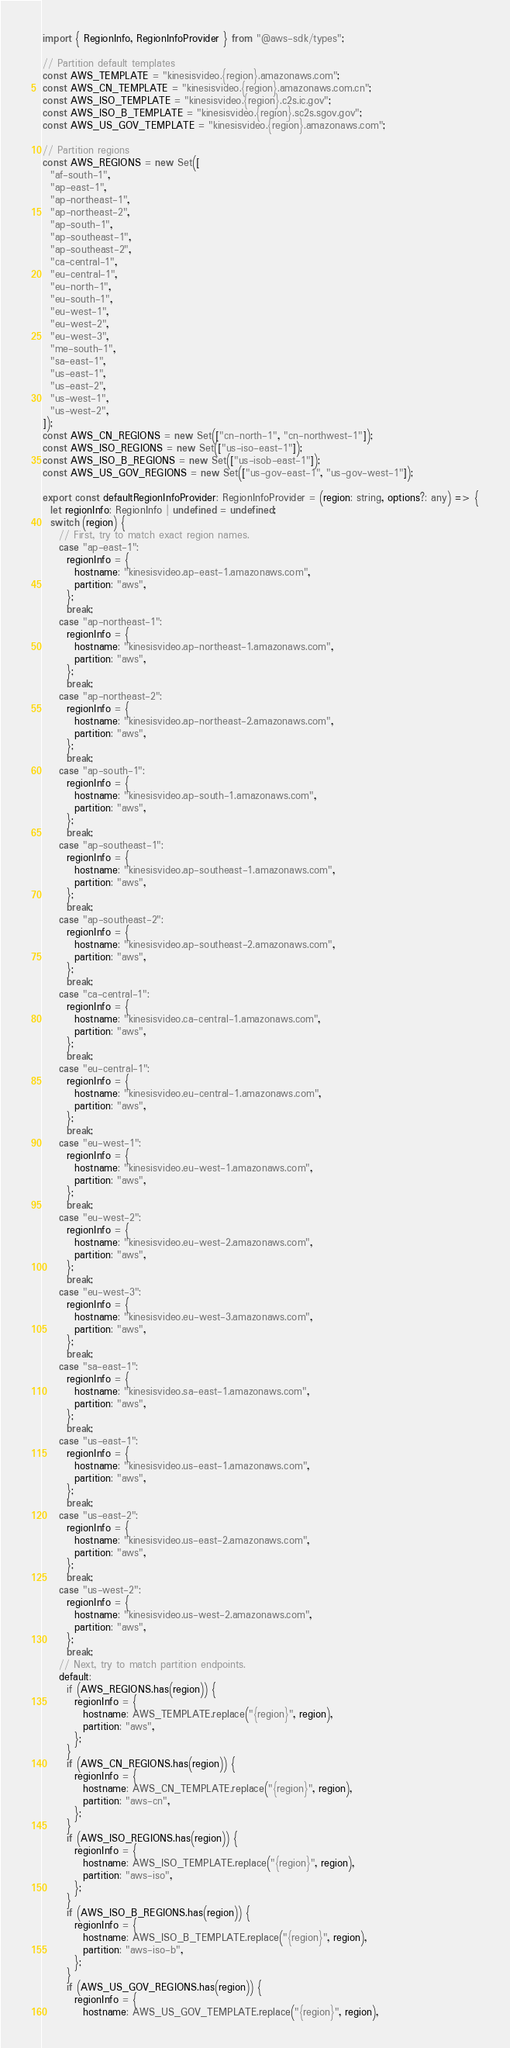<code> <loc_0><loc_0><loc_500><loc_500><_TypeScript_>import { RegionInfo, RegionInfoProvider } from "@aws-sdk/types";

// Partition default templates
const AWS_TEMPLATE = "kinesisvideo.{region}.amazonaws.com";
const AWS_CN_TEMPLATE = "kinesisvideo.{region}.amazonaws.com.cn";
const AWS_ISO_TEMPLATE = "kinesisvideo.{region}.c2s.ic.gov";
const AWS_ISO_B_TEMPLATE = "kinesisvideo.{region}.sc2s.sgov.gov";
const AWS_US_GOV_TEMPLATE = "kinesisvideo.{region}.amazonaws.com";

// Partition regions
const AWS_REGIONS = new Set([
  "af-south-1",
  "ap-east-1",
  "ap-northeast-1",
  "ap-northeast-2",
  "ap-south-1",
  "ap-southeast-1",
  "ap-southeast-2",
  "ca-central-1",
  "eu-central-1",
  "eu-north-1",
  "eu-south-1",
  "eu-west-1",
  "eu-west-2",
  "eu-west-3",
  "me-south-1",
  "sa-east-1",
  "us-east-1",
  "us-east-2",
  "us-west-1",
  "us-west-2",
]);
const AWS_CN_REGIONS = new Set(["cn-north-1", "cn-northwest-1"]);
const AWS_ISO_REGIONS = new Set(["us-iso-east-1"]);
const AWS_ISO_B_REGIONS = new Set(["us-isob-east-1"]);
const AWS_US_GOV_REGIONS = new Set(["us-gov-east-1", "us-gov-west-1"]);

export const defaultRegionInfoProvider: RegionInfoProvider = (region: string, options?: any) => {
  let regionInfo: RegionInfo | undefined = undefined;
  switch (region) {
    // First, try to match exact region names.
    case "ap-east-1":
      regionInfo = {
        hostname: "kinesisvideo.ap-east-1.amazonaws.com",
        partition: "aws",
      };
      break;
    case "ap-northeast-1":
      regionInfo = {
        hostname: "kinesisvideo.ap-northeast-1.amazonaws.com",
        partition: "aws",
      };
      break;
    case "ap-northeast-2":
      regionInfo = {
        hostname: "kinesisvideo.ap-northeast-2.amazonaws.com",
        partition: "aws",
      };
      break;
    case "ap-south-1":
      regionInfo = {
        hostname: "kinesisvideo.ap-south-1.amazonaws.com",
        partition: "aws",
      };
      break;
    case "ap-southeast-1":
      regionInfo = {
        hostname: "kinesisvideo.ap-southeast-1.amazonaws.com",
        partition: "aws",
      };
      break;
    case "ap-southeast-2":
      regionInfo = {
        hostname: "kinesisvideo.ap-southeast-2.amazonaws.com",
        partition: "aws",
      };
      break;
    case "ca-central-1":
      regionInfo = {
        hostname: "kinesisvideo.ca-central-1.amazonaws.com",
        partition: "aws",
      };
      break;
    case "eu-central-1":
      regionInfo = {
        hostname: "kinesisvideo.eu-central-1.amazonaws.com",
        partition: "aws",
      };
      break;
    case "eu-west-1":
      regionInfo = {
        hostname: "kinesisvideo.eu-west-1.amazonaws.com",
        partition: "aws",
      };
      break;
    case "eu-west-2":
      regionInfo = {
        hostname: "kinesisvideo.eu-west-2.amazonaws.com",
        partition: "aws",
      };
      break;
    case "eu-west-3":
      regionInfo = {
        hostname: "kinesisvideo.eu-west-3.amazonaws.com",
        partition: "aws",
      };
      break;
    case "sa-east-1":
      regionInfo = {
        hostname: "kinesisvideo.sa-east-1.amazonaws.com",
        partition: "aws",
      };
      break;
    case "us-east-1":
      regionInfo = {
        hostname: "kinesisvideo.us-east-1.amazonaws.com",
        partition: "aws",
      };
      break;
    case "us-east-2":
      regionInfo = {
        hostname: "kinesisvideo.us-east-2.amazonaws.com",
        partition: "aws",
      };
      break;
    case "us-west-2":
      regionInfo = {
        hostname: "kinesisvideo.us-west-2.amazonaws.com",
        partition: "aws",
      };
      break;
    // Next, try to match partition endpoints.
    default:
      if (AWS_REGIONS.has(region)) {
        regionInfo = {
          hostname: AWS_TEMPLATE.replace("{region}", region),
          partition: "aws",
        };
      }
      if (AWS_CN_REGIONS.has(region)) {
        regionInfo = {
          hostname: AWS_CN_TEMPLATE.replace("{region}", region),
          partition: "aws-cn",
        };
      }
      if (AWS_ISO_REGIONS.has(region)) {
        regionInfo = {
          hostname: AWS_ISO_TEMPLATE.replace("{region}", region),
          partition: "aws-iso",
        };
      }
      if (AWS_ISO_B_REGIONS.has(region)) {
        regionInfo = {
          hostname: AWS_ISO_B_TEMPLATE.replace("{region}", region),
          partition: "aws-iso-b",
        };
      }
      if (AWS_US_GOV_REGIONS.has(region)) {
        regionInfo = {
          hostname: AWS_US_GOV_TEMPLATE.replace("{region}", region),</code> 